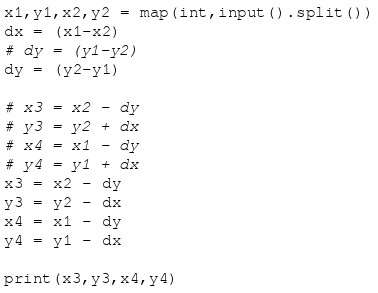Convert code to text. <code><loc_0><loc_0><loc_500><loc_500><_Python_>x1,y1,x2,y2 = map(int,input().split())
dx = (x1-x2)
# dy = (y1-y2)
dy = (y2-y1)

# x3 = x2 - dy
# y3 = y2 + dx
# x4 = x1 - dy
# y4 = y1 + dx
x3 = x2 - dy
y3 = y2 - dx
x4 = x1 - dy
y4 = y1 - dx

print(x3,y3,x4,y4)
</code> 